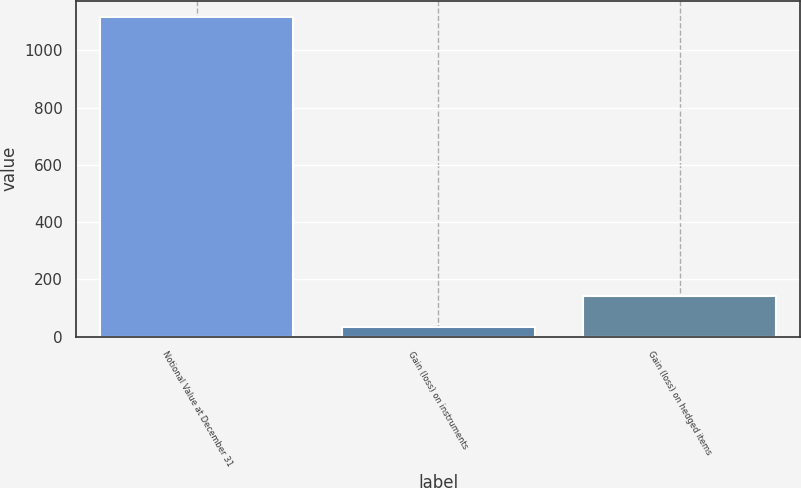<chart> <loc_0><loc_0><loc_500><loc_500><bar_chart><fcel>Notional Value at December 31<fcel>Gain (loss) on instruments<fcel>Gain (loss) on hedged items<nl><fcel>1118<fcel>35<fcel>143.3<nl></chart> 